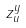<formula> <loc_0><loc_0><loc_500><loc_500>z _ { u } ^ { y }</formula> 